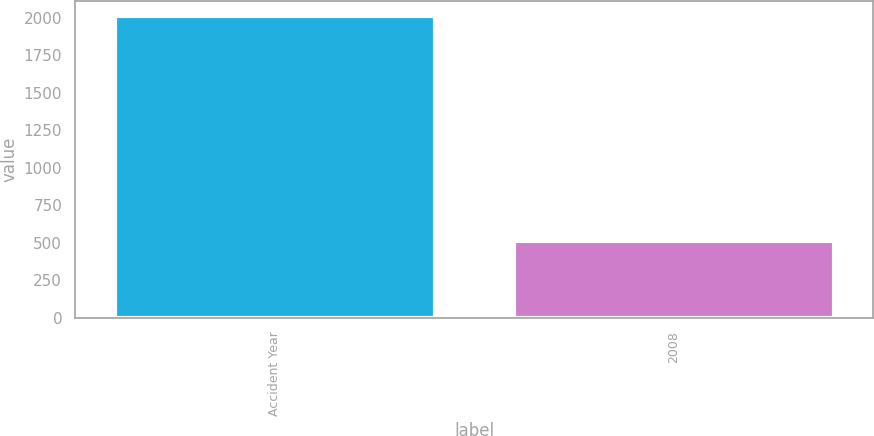<chart> <loc_0><loc_0><loc_500><loc_500><bar_chart><fcel>Accident Year<fcel>2008<nl><fcel>2010<fcel>510<nl></chart> 